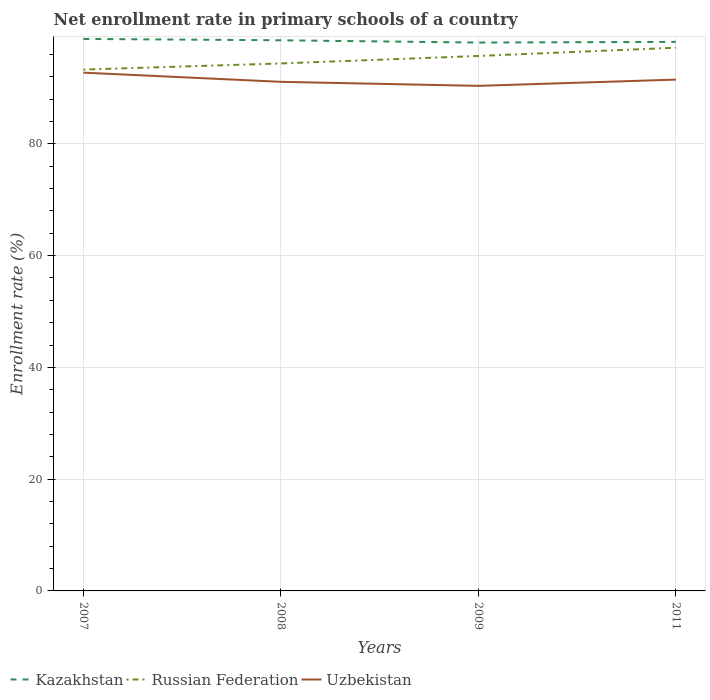How many different coloured lines are there?
Offer a very short reply. 3. Does the line corresponding to Uzbekistan intersect with the line corresponding to Russian Federation?
Your answer should be compact. No. Is the number of lines equal to the number of legend labels?
Provide a succinct answer. Yes. Across all years, what is the maximum enrollment rate in primary schools in Russian Federation?
Provide a short and direct response. 93.28. In which year was the enrollment rate in primary schools in Uzbekistan maximum?
Your answer should be very brief. 2009. What is the total enrollment rate in primary schools in Uzbekistan in the graph?
Ensure brevity in your answer.  0.72. What is the difference between the highest and the second highest enrollment rate in primary schools in Kazakhstan?
Your answer should be very brief. 0.65. Is the enrollment rate in primary schools in Uzbekistan strictly greater than the enrollment rate in primary schools in Russian Federation over the years?
Your response must be concise. Yes. How many years are there in the graph?
Keep it short and to the point. 4. What is the difference between two consecutive major ticks on the Y-axis?
Provide a succinct answer. 20. Does the graph contain any zero values?
Your response must be concise. No. Where does the legend appear in the graph?
Offer a terse response. Bottom left. What is the title of the graph?
Offer a terse response. Net enrollment rate in primary schools of a country. What is the label or title of the Y-axis?
Ensure brevity in your answer.  Enrollment rate (%). What is the Enrollment rate (%) of Kazakhstan in 2007?
Your answer should be compact. 98.77. What is the Enrollment rate (%) in Russian Federation in 2007?
Your response must be concise. 93.28. What is the Enrollment rate (%) in Uzbekistan in 2007?
Ensure brevity in your answer.  92.74. What is the Enrollment rate (%) of Kazakhstan in 2008?
Keep it short and to the point. 98.53. What is the Enrollment rate (%) of Russian Federation in 2008?
Your answer should be very brief. 94.38. What is the Enrollment rate (%) in Uzbekistan in 2008?
Offer a very short reply. 91.09. What is the Enrollment rate (%) of Kazakhstan in 2009?
Offer a very short reply. 98.12. What is the Enrollment rate (%) in Russian Federation in 2009?
Your answer should be very brief. 95.72. What is the Enrollment rate (%) of Uzbekistan in 2009?
Provide a succinct answer. 90.37. What is the Enrollment rate (%) in Kazakhstan in 2011?
Give a very brief answer. 98.24. What is the Enrollment rate (%) of Russian Federation in 2011?
Give a very brief answer. 97.2. What is the Enrollment rate (%) of Uzbekistan in 2011?
Offer a terse response. 91.49. Across all years, what is the maximum Enrollment rate (%) of Kazakhstan?
Your response must be concise. 98.77. Across all years, what is the maximum Enrollment rate (%) of Russian Federation?
Provide a succinct answer. 97.2. Across all years, what is the maximum Enrollment rate (%) in Uzbekistan?
Your answer should be compact. 92.74. Across all years, what is the minimum Enrollment rate (%) of Kazakhstan?
Provide a short and direct response. 98.12. Across all years, what is the minimum Enrollment rate (%) of Russian Federation?
Keep it short and to the point. 93.28. Across all years, what is the minimum Enrollment rate (%) of Uzbekistan?
Offer a terse response. 90.37. What is the total Enrollment rate (%) in Kazakhstan in the graph?
Ensure brevity in your answer.  393.65. What is the total Enrollment rate (%) in Russian Federation in the graph?
Your response must be concise. 380.58. What is the total Enrollment rate (%) in Uzbekistan in the graph?
Your answer should be very brief. 365.69. What is the difference between the Enrollment rate (%) in Kazakhstan in 2007 and that in 2008?
Offer a very short reply. 0.24. What is the difference between the Enrollment rate (%) of Russian Federation in 2007 and that in 2008?
Make the answer very short. -1.1. What is the difference between the Enrollment rate (%) of Uzbekistan in 2007 and that in 2008?
Make the answer very short. 1.64. What is the difference between the Enrollment rate (%) of Kazakhstan in 2007 and that in 2009?
Make the answer very short. 0.65. What is the difference between the Enrollment rate (%) of Russian Federation in 2007 and that in 2009?
Offer a very short reply. -2.44. What is the difference between the Enrollment rate (%) of Uzbekistan in 2007 and that in 2009?
Your response must be concise. 2.37. What is the difference between the Enrollment rate (%) of Kazakhstan in 2007 and that in 2011?
Make the answer very short. 0.53. What is the difference between the Enrollment rate (%) in Russian Federation in 2007 and that in 2011?
Make the answer very short. -3.92. What is the difference between the Enrollment rate (%) of Uzbekistan in 2007 and that in 2011?
Keep it short and to the point. 1.25. What is the difference between the Enrollment rate (%) of Kazakhstan in 2008 and that in 2009?
Provide a short and direct response. 0.41. What is the difference between the Enrollment rate (%) in Russian Federation in 2008 and that in 2009?
Ensure brevity in your answer.  -1.34. What is the difference between the Enrollment rate (%) in Uzbekistan in 2008 and that in 2009?
Give a very brief answer. 0.72. What is the difference between the Enrollment rate (%) in Kazakhstan in 2008 and that in 2011?
Your answer should be very brief. 0.29. What is the difference between the Enrollment rate (%) in Russian Federation in 2008 and that in 2011?
Offer a very short reply. -2.82. What is the difference between the Enrollment rate (%) of Uzbekistan in 2008 and that in 2011?
Keep it short and to the point. -0.4. What is the difference between the Enrollment rate (%) in Kazakhstan in 2009 and that in 2011?
Give a very brief answer. -0.12. What is the difference between the Enrollment rate (%) of Russian Federation in 2009 and that in 2011?
Provide a short and direct response. -1.48. What is the difference between the Enrollment rate (%) of Uzbekistan in 2009 and that in 2011?
Give a very brief answer. -1.12. What is the difference between the Enrollment rate (%) of Kazakhstan in 2007 and the Enrollment rate (%) of Russian Federation in 2008?
Offer a terse response. 4.39. What is the difference between the Enrollment rate (%) in Kazakhstan in 2007 and the Enrollment rate (%) in Uzbekistan in 2008?
Provide a short and direct response. 7.68. What is the difference between the Enrollment rate (%) of Russian Federation in 2007 and the Enrollment rate (%) of Uzbekistan in 2008?
Make the answer very short. 2.19. What is the difference between the Enrollment rate (%) of Kazakhstan in 2007 and the Enrollment rate (%) of Russian Federation in 2009?
Provide a succinct answer. 3.05. What is the difference between the Enrollment rate (%) in Kazakhstan in 2007 and the Enrollment rate (%) in Uzbekistan in 2009?
Provide a short and direct response. 8.4. What is the difference between the Enrollment rate (%) of Russian Federation in 2007 and the Enrollment rate (%) of Uzbekistan in 2009?
Give a very brief answer. 2.91. What is the difference between the Enrollment rate (%) of Kazakhstan in 2007 and the Enrollment rate (%) of Russian Federation in 2011?
Your answer should be compact. 1.57. What is the difference between the Enrollment rate (%) in Kazakhstan in 2007 and the Enrollment rate (%) in Uzbekistan in 2011?
Make the answer very short. 7.28. What is the difference between the Enrollment rate (%) in Russian Federation in 2007 and the Enrollment rate (%) in Uzbekistan in 2011?
Your answer should be compact. 1.79. What is the difference between the Enrollment rate (%) in Kazakhstan in 2008 and the Enrollment rate (%) in Russian Federation in 2009?
Give a very brief answer. 2.81. What is the difference between the Enrollment rate (%) in Kazakhstan in 2008 and the Enrollment rate (%) in Uzbekistan in 2009?
Your answer should be very brief. 8.16. What is the difference between the Enrollment rate (%) in Russian Federation in 2008 and the Enrollment rate (%) in Uzbekistan in 2009?
Give a very brief answer. 4.01. What is the difference between the Enrollment rate (%) in Kazakhstan in 2008 and the Enrollment rate (%) in Russian Federation in 2011?
Make the answer very short. 1.33. What is the difference between the Enrollment rate (%) of Kazakhstan in 2008 and the Enrollment rate (%) of Uzbekistan in 2011?
Give a very brief answer. 7.04. What is the difference between the Enrollment rate (%) of Russian Federation in 2008 and the Enrollment rate (%) of Uzbekistan in 2011?
Your answer should be compact. 2.89. What is the difference between the Enrollment rate (%) of Kazakhstan in 2009 and the Enrollment rate (%) of Russian Federation in 2011?
Provide a succinct answer. 0.92. What is the difference between the Enrollment rate (%) of Kazakhstan in 2009 and the Enrollment rate (%) of Uzbekistan in 2011?
Ensure brevity in your answer.  6.63. What is the difference between the Enrollment rate (%) of Russian Federation in 2009 and the Enrollment rate (%) of Uzbekistan in 2011?
Your answer should be very brief. 4.23. What is the average Enrollment rate (%) in Kazakhstan per year?
Your answer should be very brief. 98.41. What is the average Enrollment rate (%) of Russian Federation per year?
Provide a succinct answer. 95.14. What is the average Enrollment rate (%) of Uzbekistan per year?
Your answer should be compact. 91.42. In the year 2007, what is the difference between the Enrollment rate (%) of Kazakhstan and Enrollment rate (%) of Russian Federation?
Offer a very short reply. 5.49. In the year 2007, what is the difference between the Enrollment rate (%) in Kazakhstan and Enrollment rate (%) in Uzbekistan?
Offer a terse response. 6.03. In the year 2007, what is the difference between the Enrollment rate (%) of Russian Federation and Enrollment rate (%) of Uzbekistan?
Ensure brevity in your answer.  0.55. In the year 2008, what is the difference between the Enrollment rate (%) of Kazakhstan and Enrollment rate (%) of Russian Federation?
Offer a very short reply. 4.15. In the year 2008, what is the difference between the Enrollment rate (%) in Kazakhstan and Enrollment rate (%) in Uzbekistan?
Your response must be concise. 7.43. In the year 2008, what is the difference between the Enrollment rate (%) of Russian Federation and Enrollment rate (%) of Uzbekistan?
Keep it short and to the point. 3.29. In the year 2009, what is the difference between the Enrollment rate (%) of Kazakhstan and Enrollment rate (%) of Russian Federation?
Your answer should be compact. 2.4. In the year 2009, what is the difference between the Enrollment rate (%) of Kazakhstan and Enrollment rate (%) of Uzbekistan?
Give a very brief answer. 7.75. In the year 2009, what is the difference between the Enrollment rate (%) in Russian Federation and Enrollment rate (%) in Uzbekistan?
Offer a terse response. 5.35. In the year 2011, what is the difference between the Enrollment rate (%) in Kazakhstan and Enrollment rate (%) in Russian Federation?
Make the answer very short. 1.04. In the year 2011, what is the difference between the Enrollment rate (%) in Kazakhstan and Enrollment rate (%) in Uzbekistan?
Offer a very short reply. 6.75. In the year 2011, what is the difference between the Enrollment rate (%) of Russian Federation and Enrollment rate (%) of Uzbekistan?
Ensure brevity in your answer.  5.71. What is the ratio of the Enrollment rate (%) in Kazakhstan in 2007 to that in 2008?
Ensure brevity in your answer.  1. What is the ratio of the Enrollment rate (%) of Russian Federation in 2007 to that in 2008?
Ensure brevity in your answer.  0.99. What is the ratio of the Enrollment rate (%) in Kazakhstan in 2007 to that in 2009?
Keep it short and to the point. 1.01. What is the ratio of the Enrollment rate (%) in Russian Federation in 2007 to that in 2009?
Give a very brief answer. 0.97. What is the ratio of the Enrollment rate (%) of Uzbekistan in 2007 to that in 2009?
Keep it short and to the point. 1.03. What is the ratio of the Enrollment rate (%) of Kazakhstan in 2007 to that in 2011?
Keep it short and to the point. 1.01. What is the ratio of the Enrollment rate (%) of Russian Federation in 2007 to that in 2011?
Give a very brief answer. 0.96. What is the ratio of the Enrollment rate (%) in Uzbekistan in 2007 to that in 2011?
Provide a succinct answer. 1.01. What is the ratio of the Enrollment rate (%) in Kazakhstan in 2008 to that in 2009?
Make the answer very short. 1. What is the ratio of the Enrollment rate (%) of Kazakhstan in 2008 to that in 2011?
Provide a short and direct response. 1. What is the ratio of the Enrollment rate (%) in Russian Federation in 2008 to that in 2011?
Make the answer very short. 0.97. What is the ratio of the Enrollment rate (%) in Uzbekistan in 2009 to that in 2011?
Offer a very short reply. 0.99. What is the difference between the highest and the second highest Enrollment rate (%) of Kazakhstan?
Your answer should be very brief. 0.24. What is the difference between the highest and the second highest Enrollment rate (%) in Russian Federation?
Your answer should be compact. 1.48. What is the difference between the highest and the second highest Enrollment rate (%) in Uzbekistan?
Offer a terse response. 1.25. What is the difference between the highest and the lowest Enrollment rate (%) in Kazakhstan?
Your response must be concise. 0.65. What is the difference between the highest and the lowest Enrollment rate (%) of Russian Federation?
Give a very brief answer. 3.92. What is the difference between the highest and the lowest Enrollment rate (%) in Uzbekistan?
Provide a succinct answer. 2.37. 